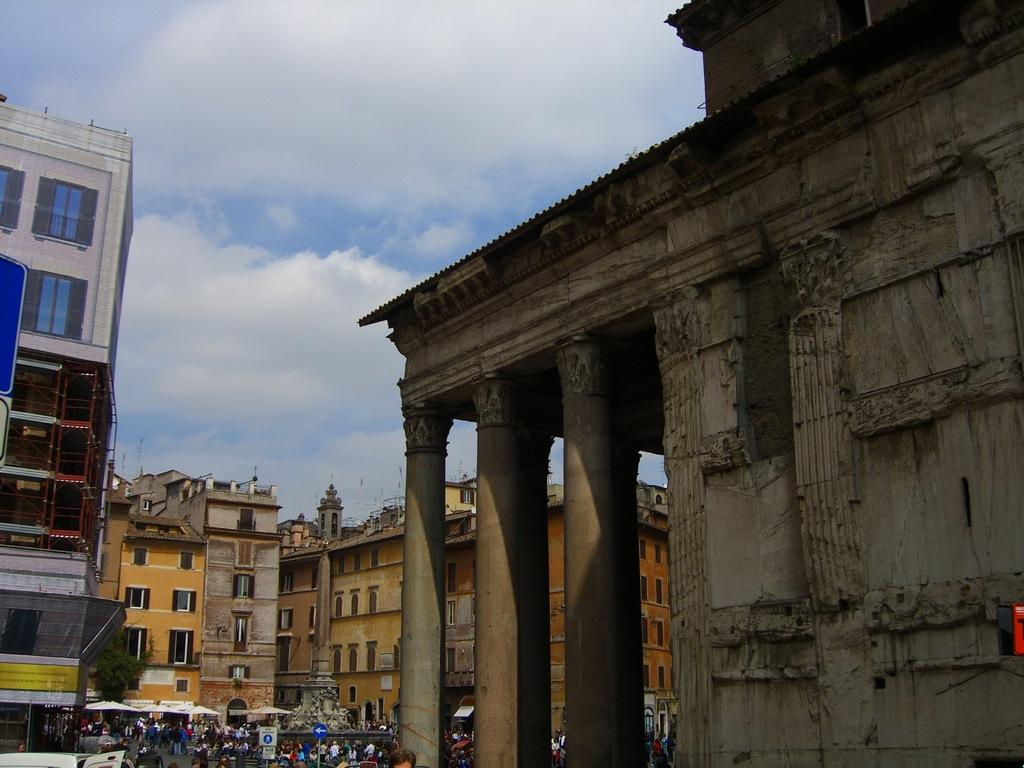Who or what can be seen in the image? There are people in the image. What type of structures are visible in the image? There are buildings in the image. What architectural elements can be seen in the image? Pillars are present in the image. What objects are visible in the image? Boards and poles are in the image. What type of shade provider is present in the image? Patio umbrellas are present in the image. What type of vegetation is in the image? There is a tree in the image. What can be seen in the background of the image? The sky is visible in the background of the image. How many frogs are sitting on the patio umbrellas in the image? There are no frogs present in the image. Who is the expert in the image? There is no specific expert mentioned or depicted in the image. 